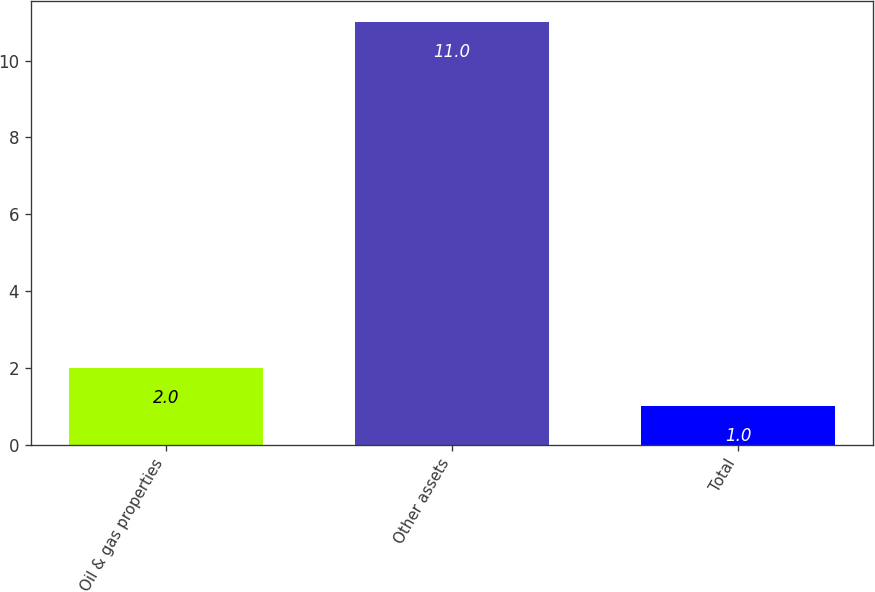<chart> <loc_0><loc_0><loc_500><loc_500><bar_chart><fcel>Oil & gas properties<fcel>Other assets<fcel>Total<nl><fcel>2<fcel>11<fcel>1<nl></chart> 